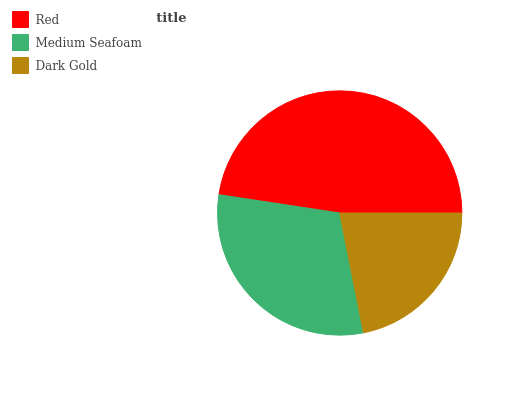Is Dark Gold the minimum?
Answer yes or no. Yes. Is Red the maximum?
Answer yes or no. Yes. Is Medium Seafoam the minimum?
Answer yes or no. No. Is Medium Seafoam the maximum?
Answer yes or no. No. Is Red greater than Medium Seafoam?
Answer yes or no. Yes. Is Medium Seafoam less than Red?
Answer yes or no. Yes. Is Medium Seafoam greater than Red?
Answer yes or no. No. Is Red less than Medium Seafoam?
Answer yes or no. No. Is Medium Seafoam the high median?
Answer yes or no. Yes. Is Medium Seafoam the low median?
Answer yes or no. Yes. Is Dark Gold the high median?
Answer yes or no. No. Is Dark Gold the low median?
Answer yes or no. No. 